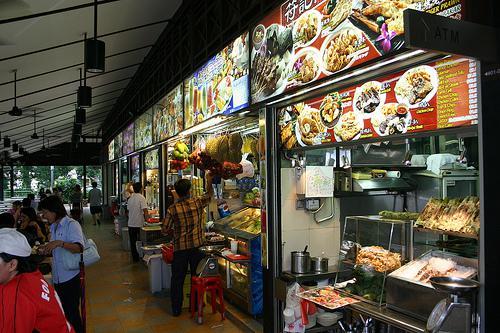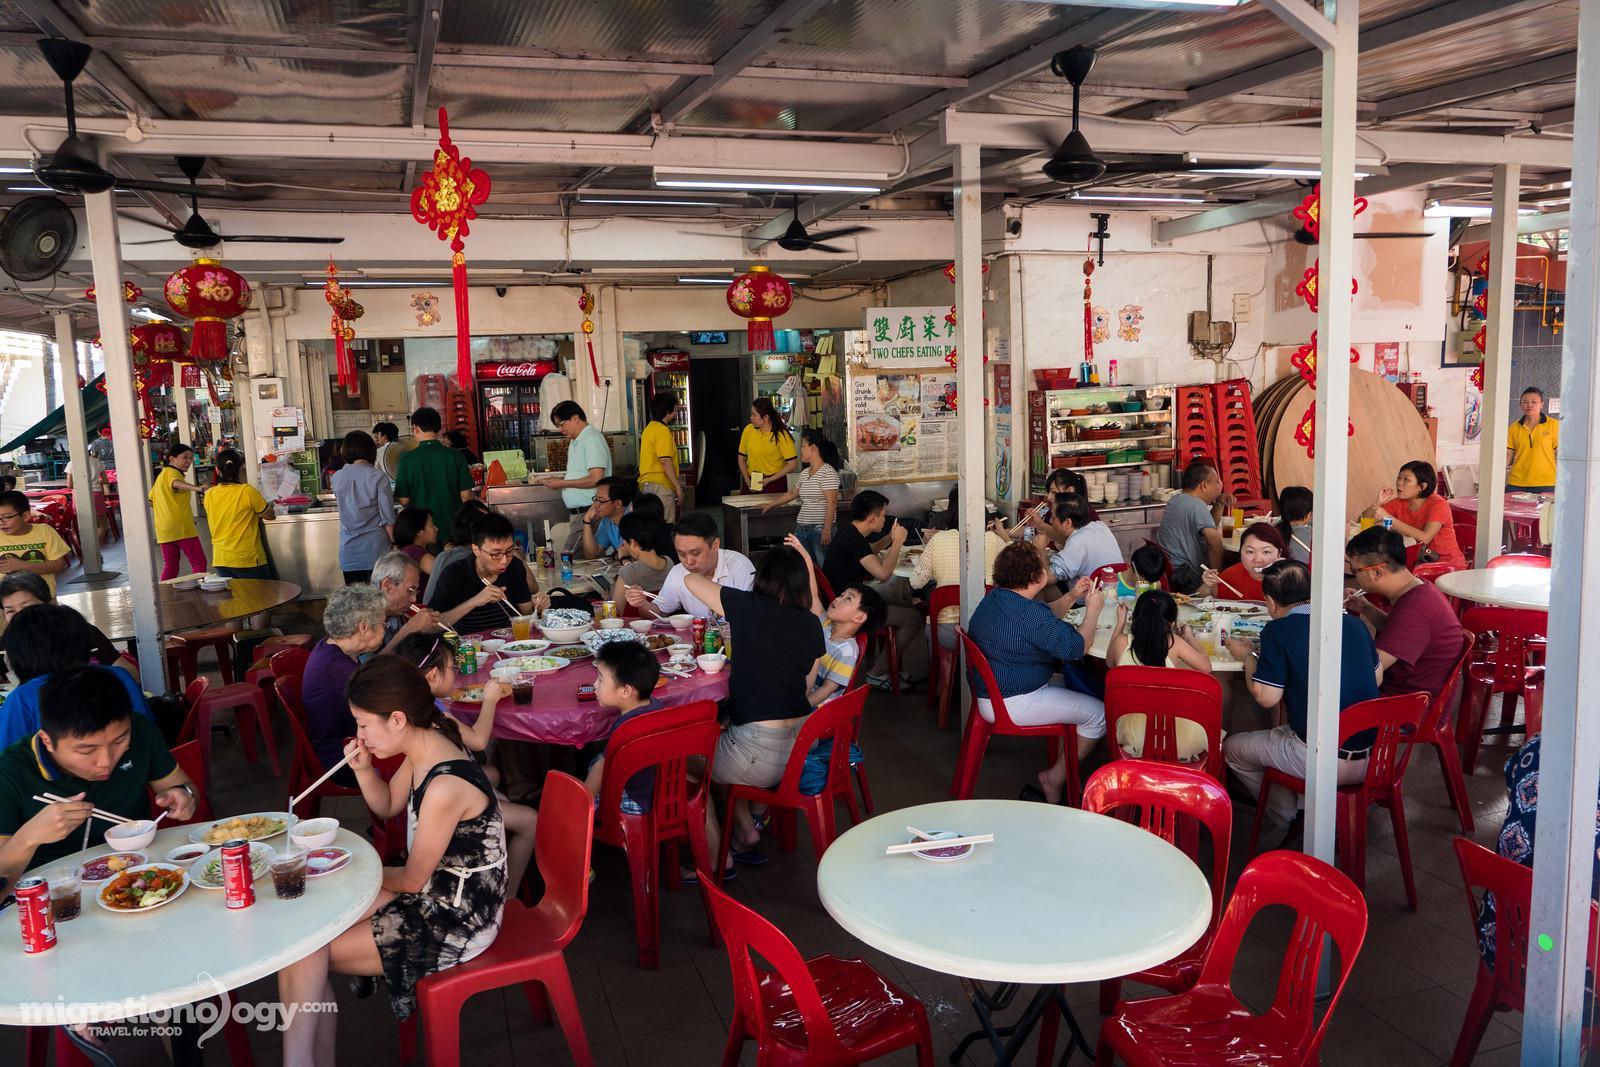The first image is the image on the left, the second image is the image on the right. Given the left and right images, does the statement "An image shows a diner with green Chinese characters on a black rectangle at the top front, and a row of lighted horizontal rectangles above a diamond-tile pattern in the background." hold true? Answer yes or no. No. The first image is the image on the left, the second image is the image on the right. Given the left and right images, does the statement "IN at least one image there is greenery next to an outside cafe." hold true? Answer yes or no. No. 